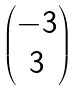<formula> <loc_0><loc_0><loc_500><loc_500>\begin{pmatrix} - 3 \\ 3 \end{pmatrix}</formula> 